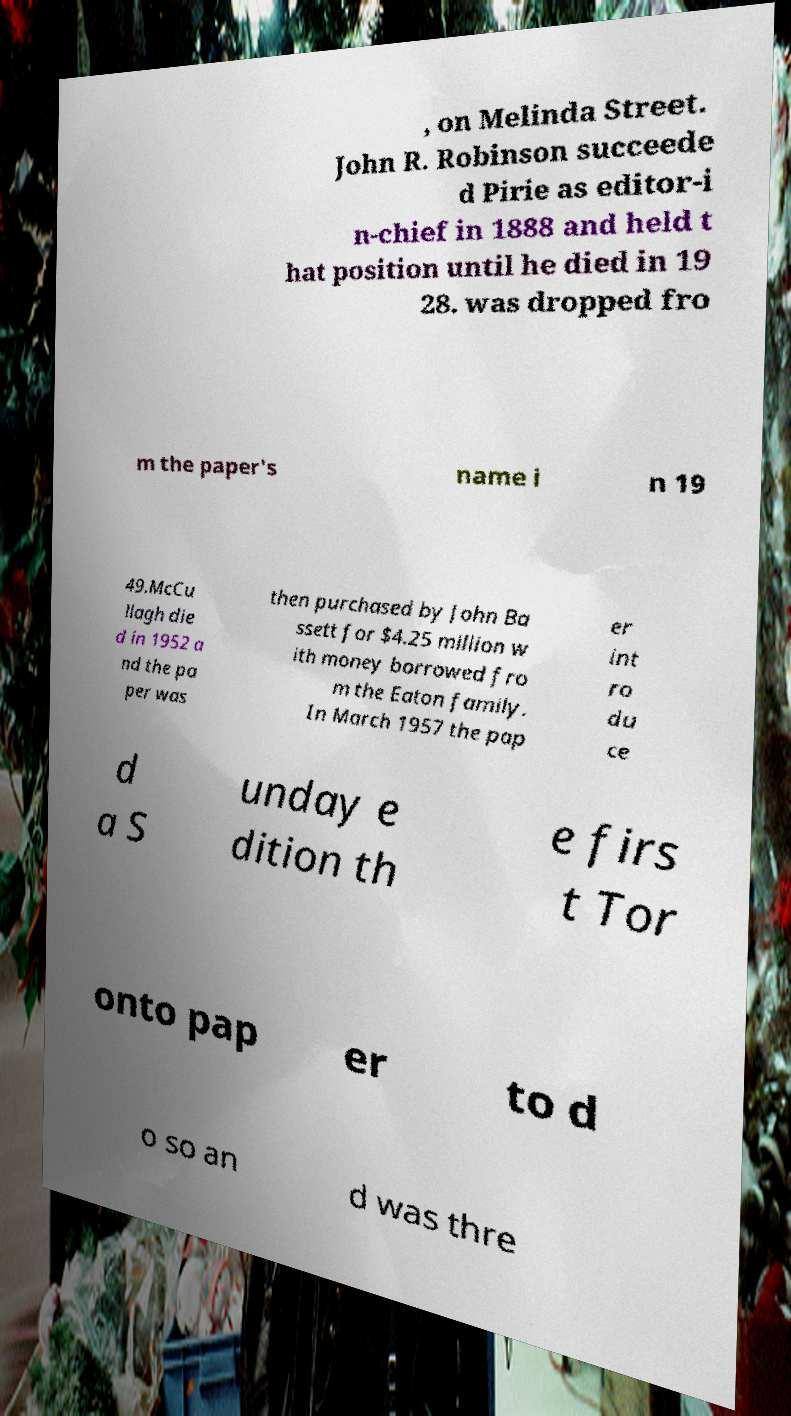Could you assist in decoding the text presented in this image and type it out clearly? , on Melinda Street. John R. Robinson succeede d Pirie as editor-i n-chief in 1888 and held t hat position until he died in 19 28. was dropped fro m the paper's name i n 19 49.McCu llagh die d in 1952 a nd the pa per was then purchased by John Ba ssett for $4.25 million w ith money borrowed fro m the Eaton family. In March 1957 the pap er int ro du ce d a S unday e dition th e firs t Tor onto pap er to d o so an d was thre 